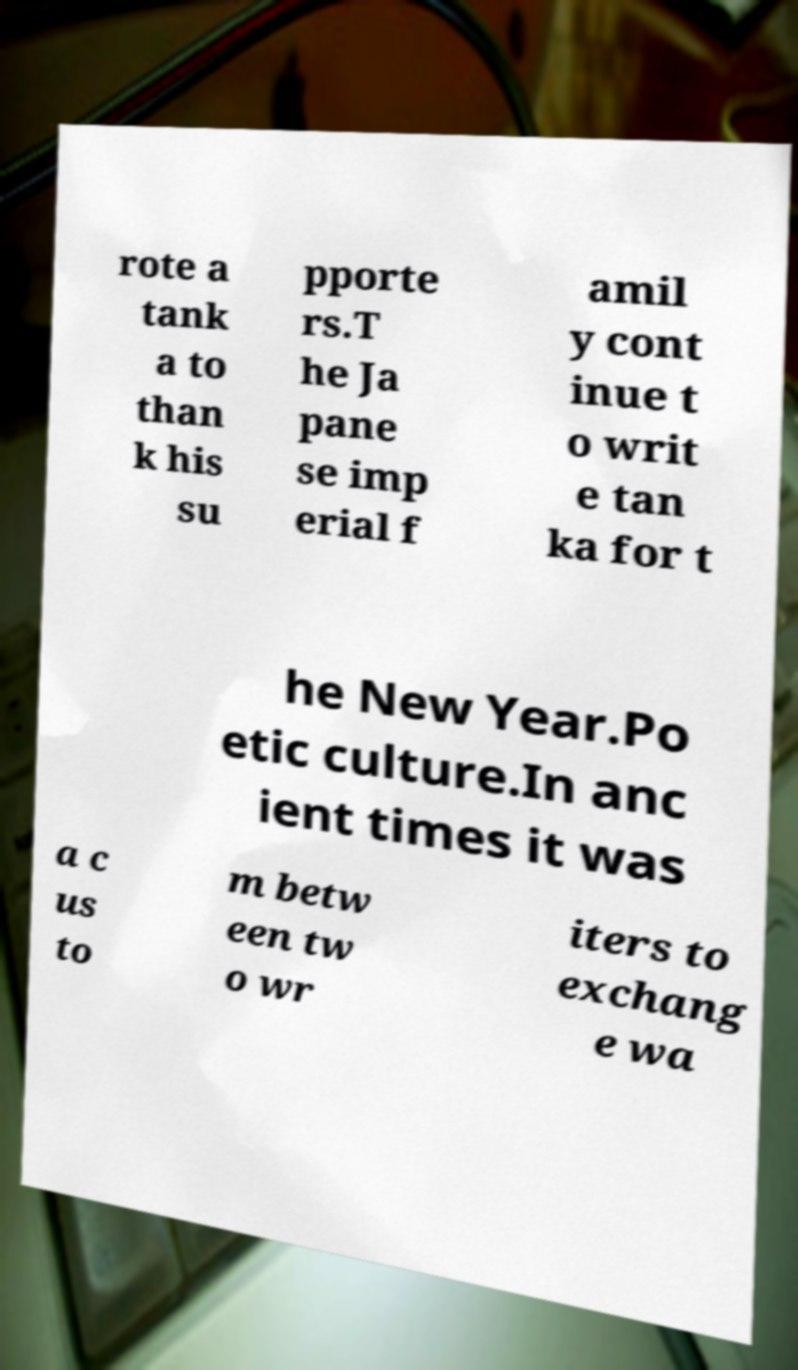Could you assist in decoding the text presented in this image and type it out clearly? rote a tank a to than k his su pporte rs.T he Ja pane se imp erial f amil y cont inue t o writ e tan ka for t he New Year.Po etic culture.In anc ient times it was a c us to m betw een tw o wr iters to exchang e wa 